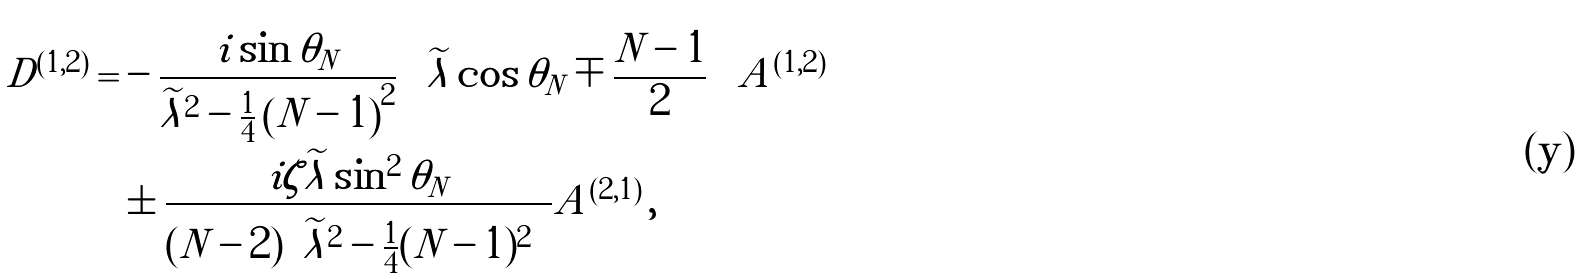<formula> <loc_0><loc_0><loc_500><loc_500>D ^ { ( 1 , 2 ) } = & - \frac { i \sin \theta _ { N } } { \widetilde { \lambda } ^ { 2 } - \frac { 1 } { 4 } \left ( N - 1 \right ) ^ { 2 } } \left ( \widetilde { \lambda } \cos \theta _ { N } \mp \frac { N - 1 } { 2 } \right ) A ^ { ( 1 , 2 ) } \\ & \pm \frac { i \zeta \widetilde { \lambda } \sin ^ { 2 } \theta _ { N } } { ( N - 2 ) \left ( \widetilde { \lambda } ^ { 2 } - \frac { 1 } { 4 } ( N - 1 ) ^ { 2 } \right ) } A ^ { ( 2 , 1 ) } \, ,</formula> 